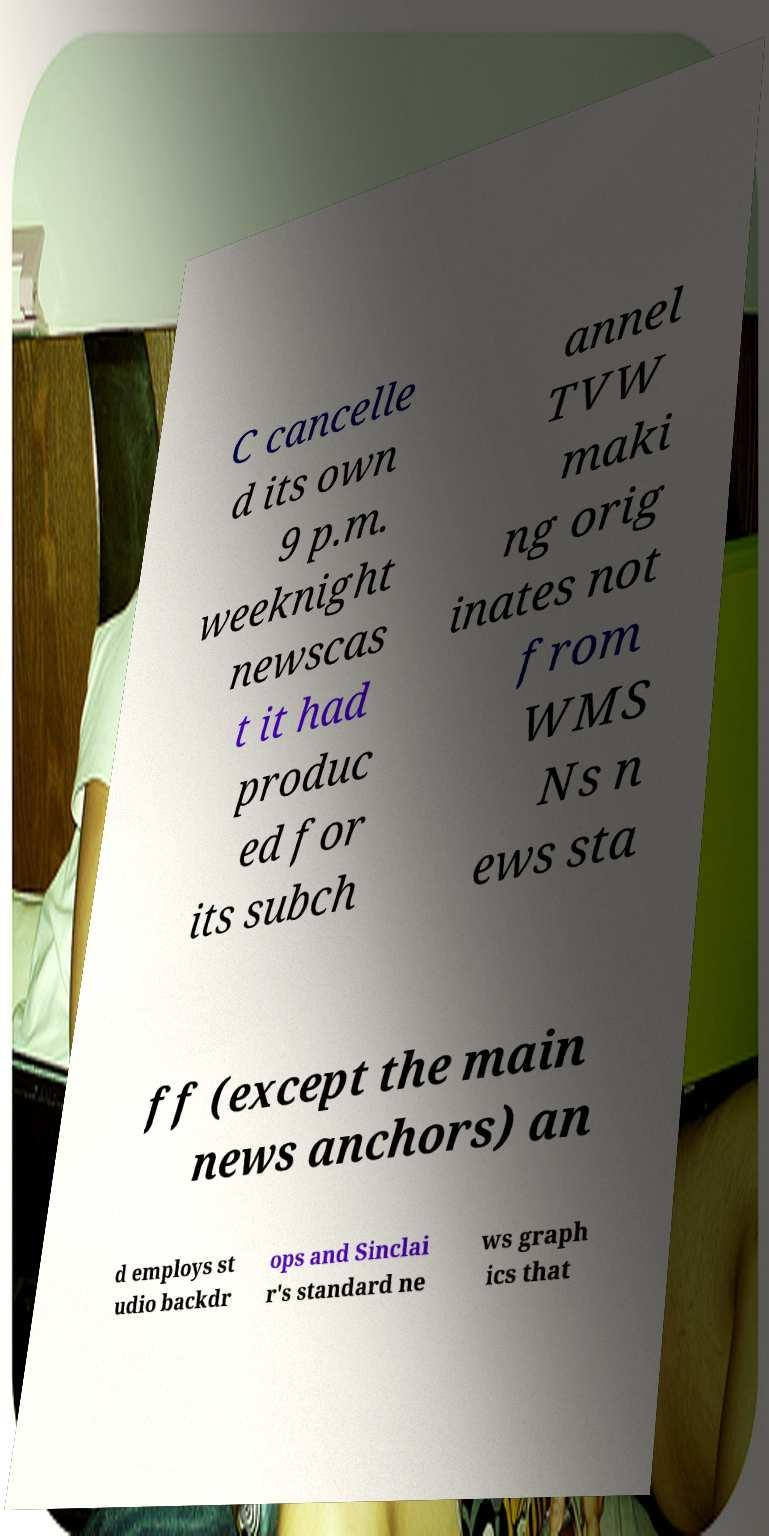For documentation purposes, I need the text within this image transcribed. Could you provide that? C cancelle d its own 9 p.m. weeknight newscas t it had produc ed for its subch annel TVW maki ng orig inates not from WMS Ns n ews sta ff (except the main news anchors) an d employs st udio backdr ops and Sinclai r's standard ne ws graph ics that 